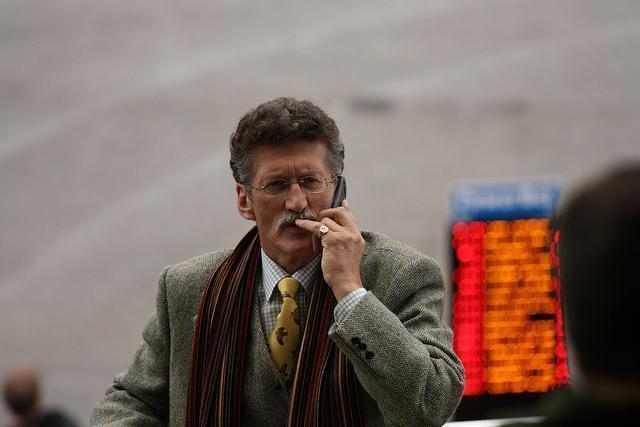What is the man with the mustache doing with the black object?
Answer the question by selecting the correct answer among the 4 following choices.
Options: Gaming, paying, exercising, calling. Calling. 